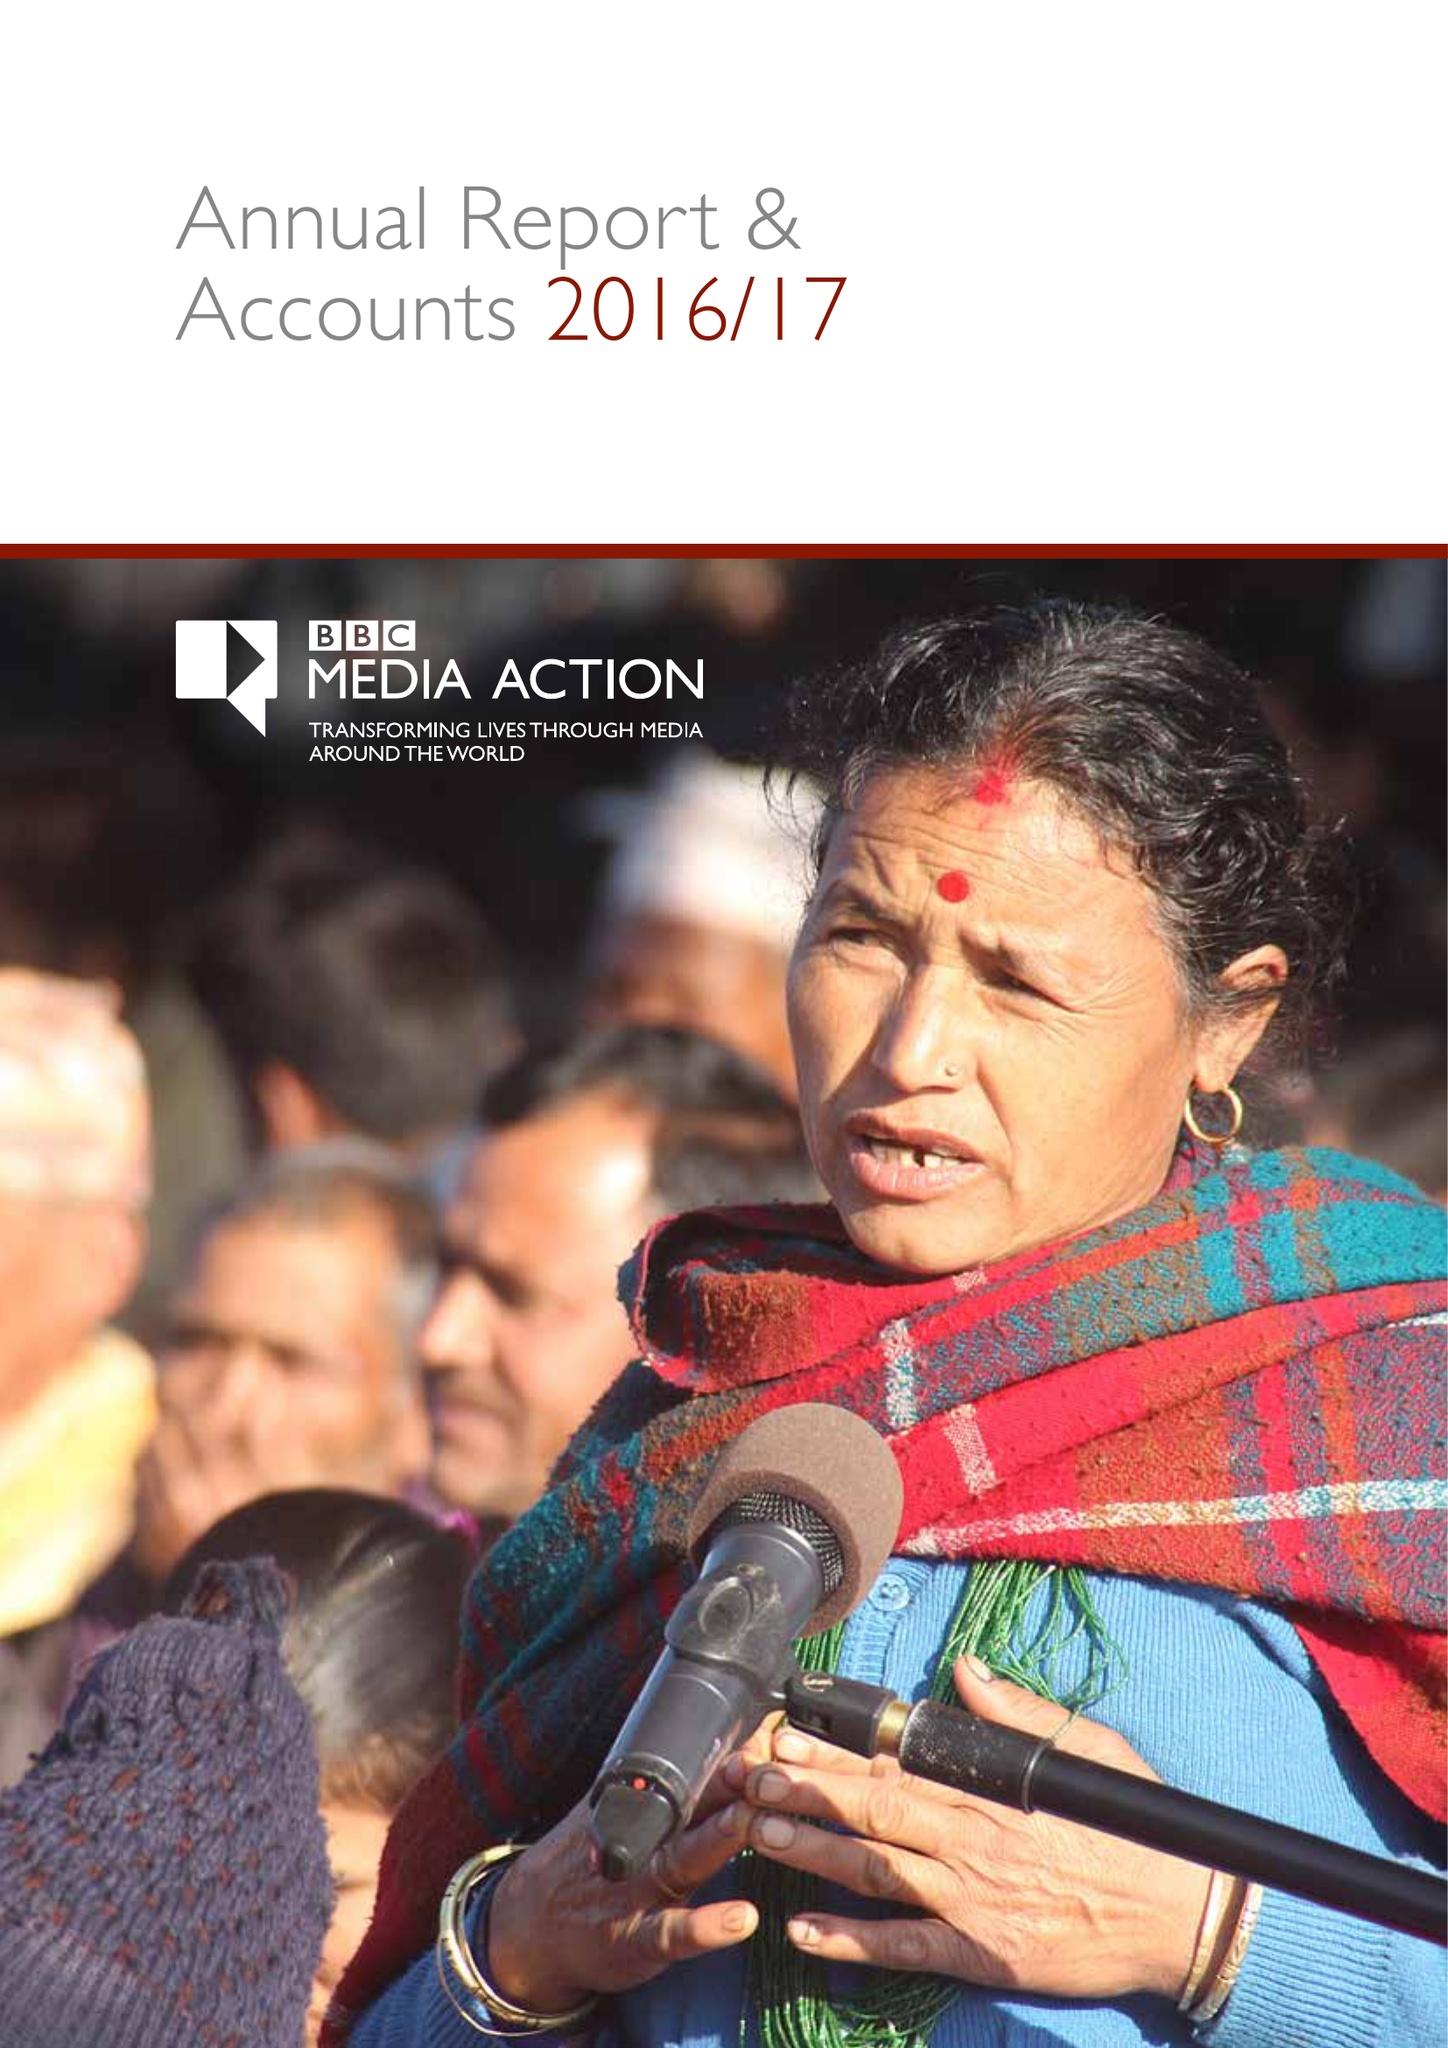What is the value for the report_date?
Answer the question using a single word or phrase. 2017-03-31 